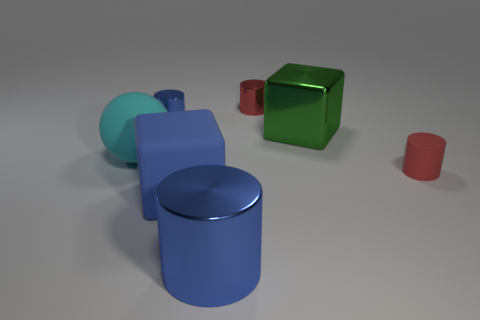Is there anything else that is the same shape as the large cyan rubber thing?
Your response must be concise. No. There is a big blue object behind the blue metallic cylinder in front of the tiny red rubber thing; what is its shape?
Your response must be concise. Cube. There is a red thing in front of the big cube that is to the right of the big matte thing in front of the matte cylinder; how big is it?
Your response must be concise. Small. Do the cyan matte thing and the red metallic thing have the same size?
Offer a terse response. No. What number of objects are tiny yellow cylinders or metallic objects?
Give a very brief answer. 4. What size is the blue metallic cylinder that is on the left side of the shiny cylinder in front of the large green shiny object?
Provide a short and direct response. Small. How big is the red rubber thing?
Make the answer very short. Small. What is the shape of the tiny object that is both on the right side of the blue rubber cube and to the left of the red rubber cylinder?
Offer a terse response. Cylinder. The other large thing that is the same shape as the large green object is what color?
Provide a succinct answer. Blue. What number of objects are either red cylinders that are behind the big cyan matte sphere or large metal things that are left of the green metal object?
Offer a terse response. 2. 